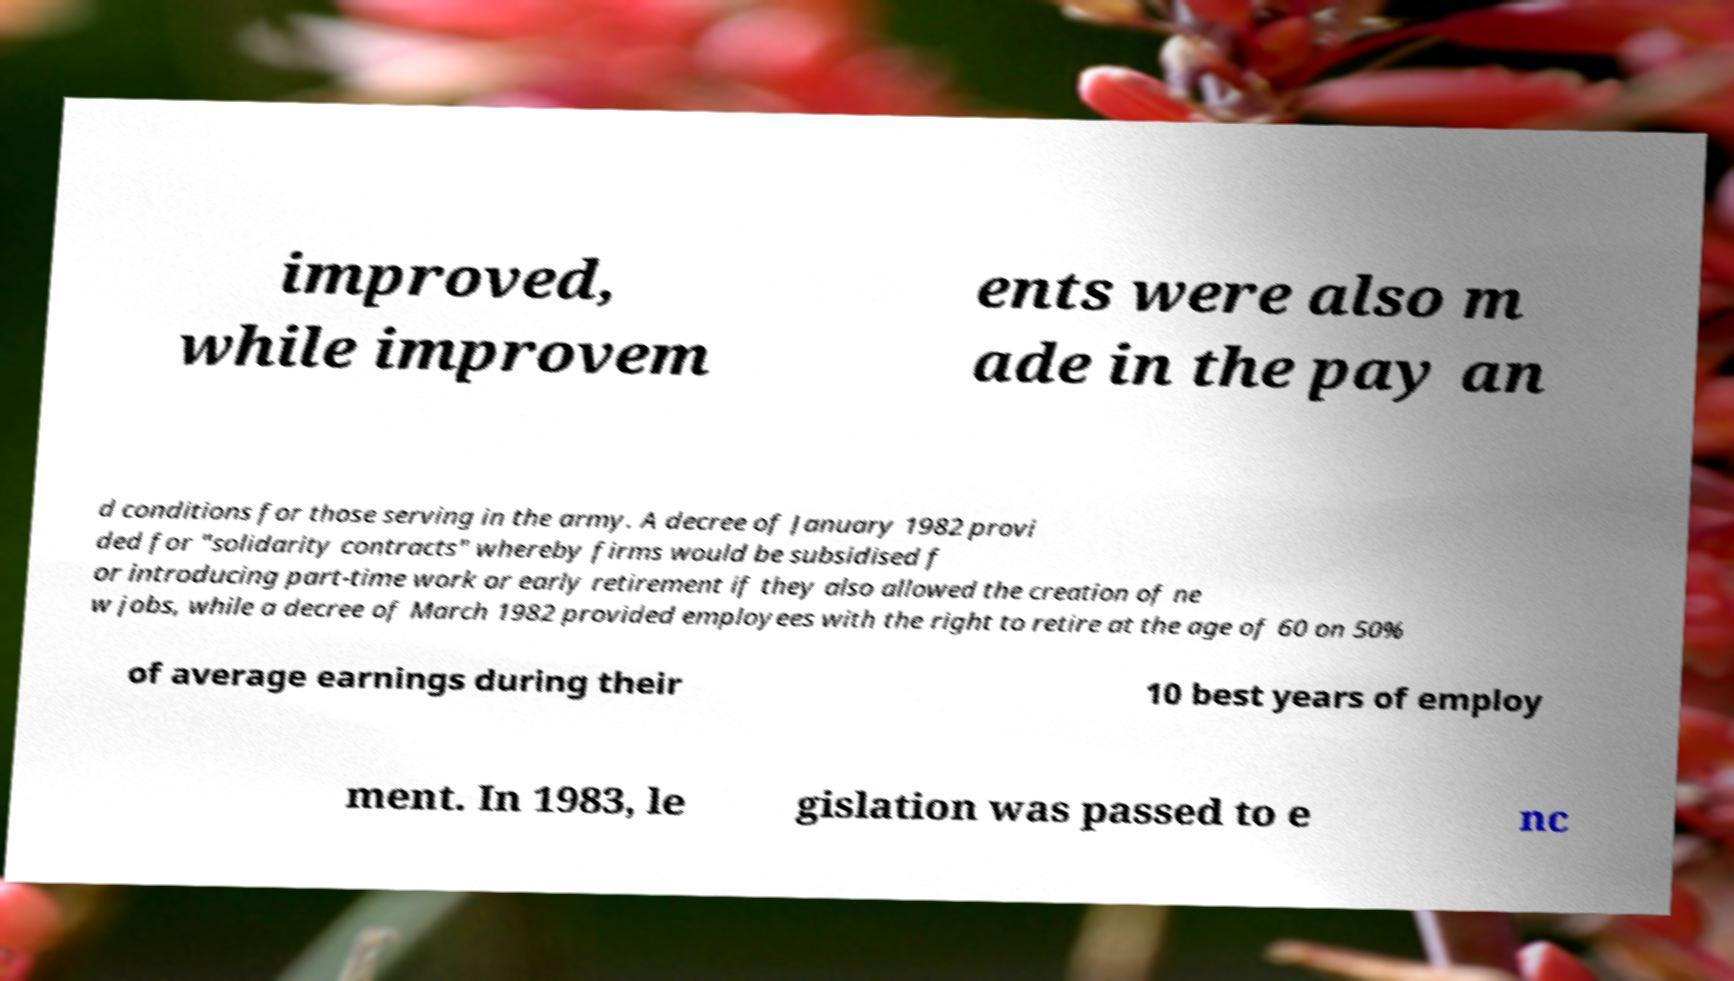Could you extract and type out the text from this image? improved, while improvem ents were also m ade in the pay an d conditions for those serving in the army. A decree of January 1982 provi ded for "solidarity contracts" whereby firms would be subsidised f or introducing part-time work or early retirement if they also allowed the creation of ne w jobs, while a decree of March 1982 provided employees with the right to retire at the age of 60 on 50% of average earnings during their 10 best years of employ ment. In 1983, le gislation was passed to e nc 